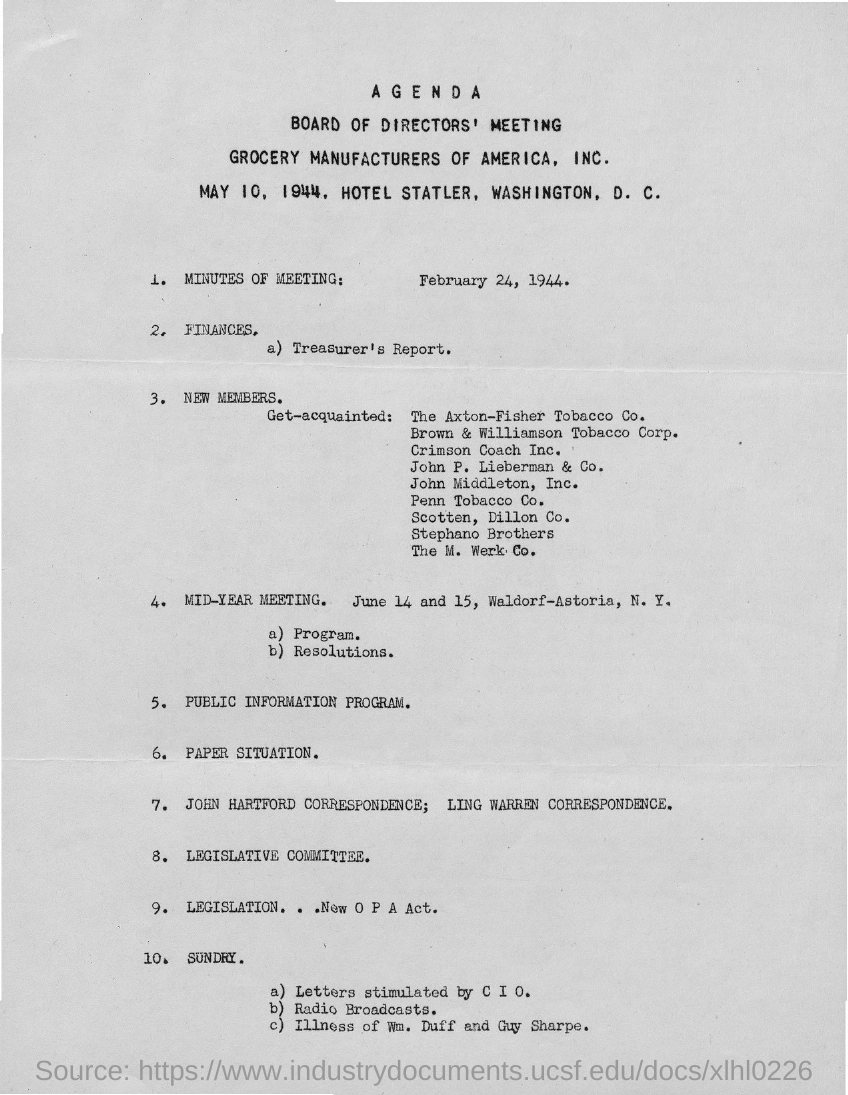Point out several critical features in this image. The Board of Directors of Grocery Manufacturers of America, Inc. holds its meetings at the Hotel Statler in Washington, D.C. The mid-year meeting will take place on June 14 and 15 at the Waldorf-Astoria hotel in New York. The board of directors' meeting of Grocery Manufacturers of America, Inc. was held on May 10, 1944. 